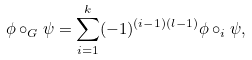<formula> <loc_0><loc_0><loc_500><loc_500>\phi \circ _ { G } \psi = \sum _ { i = 1 } ^ { k } ( - 1 ) ^ { ( i - 1 ) ( l - 1 ) } \phi \circ _ { i } \psi ,</formula> 